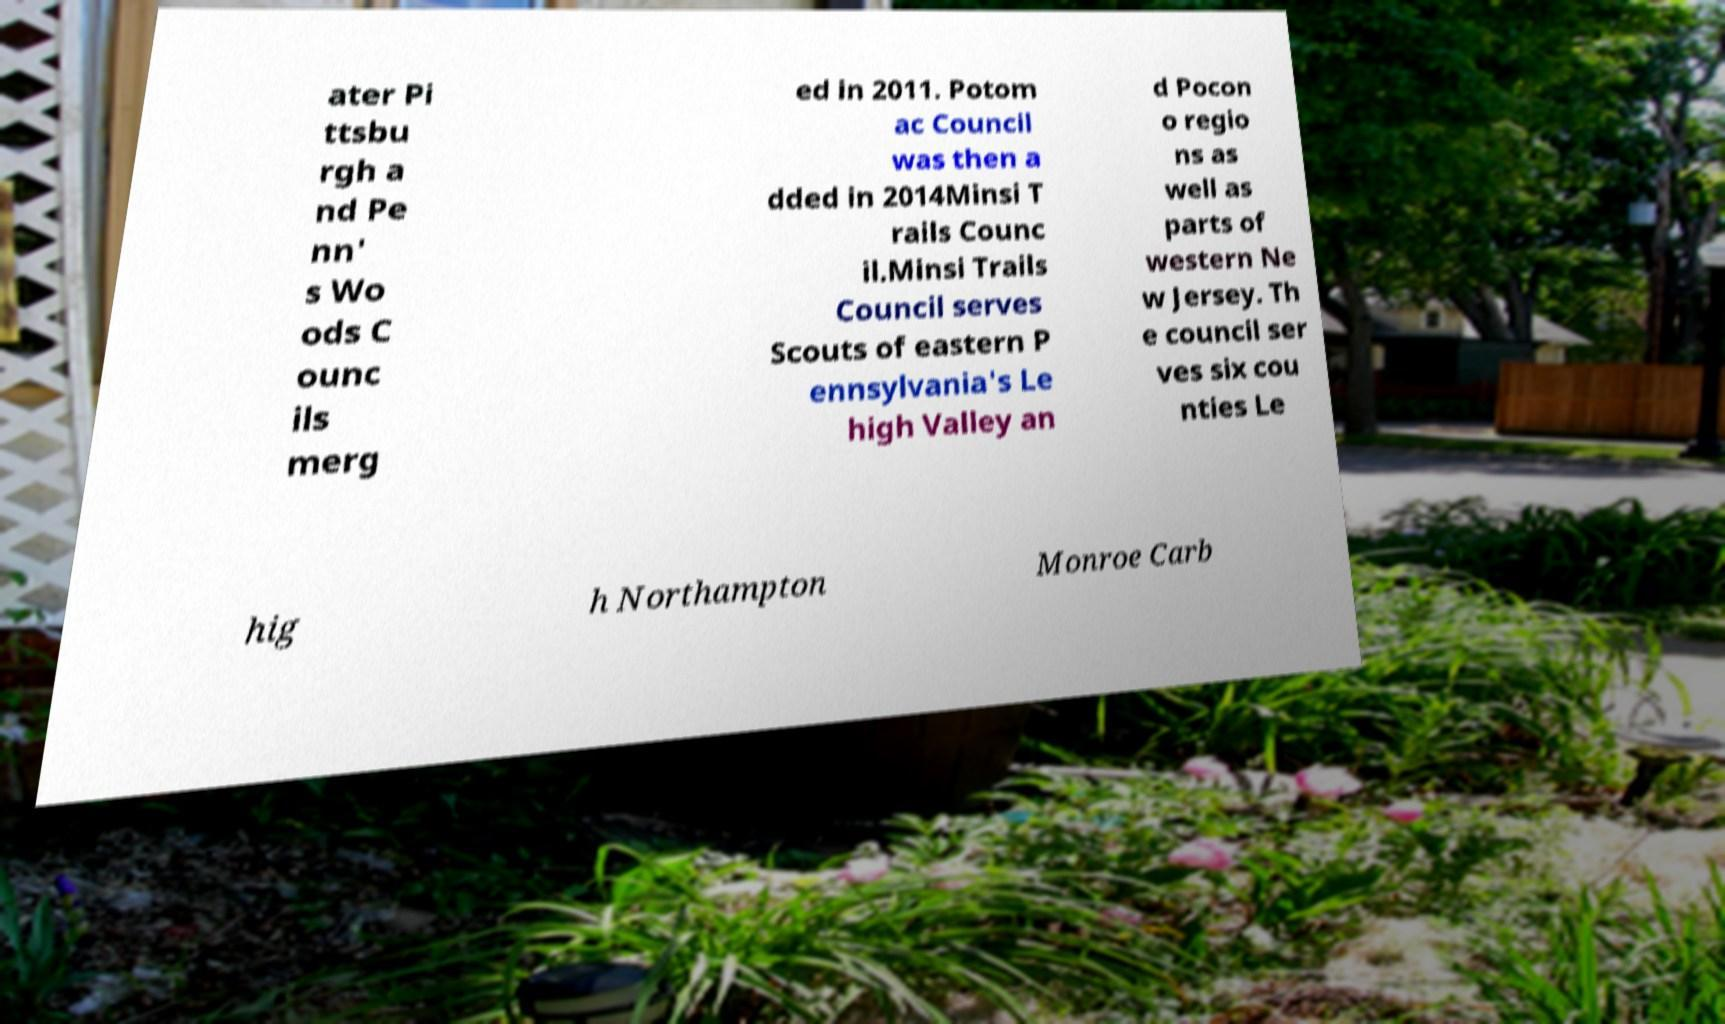Please read and relay the text visible in this image. What does it say? ater Pi ttsbu rgh a nd Pe nn' s Wo ods C ounc ils merg ed in 2011. Potom ac Council was then a dded in 2014Minsi T rails Counc il.Minsi Trails Council serves Scouts of eastern P ennsylvania's Le high Valley an d Pocon o regio ns as well as parts of western Ne w Jersey. Th e council ser ves six cou nties Le hig h Northampton Monroe Carb 